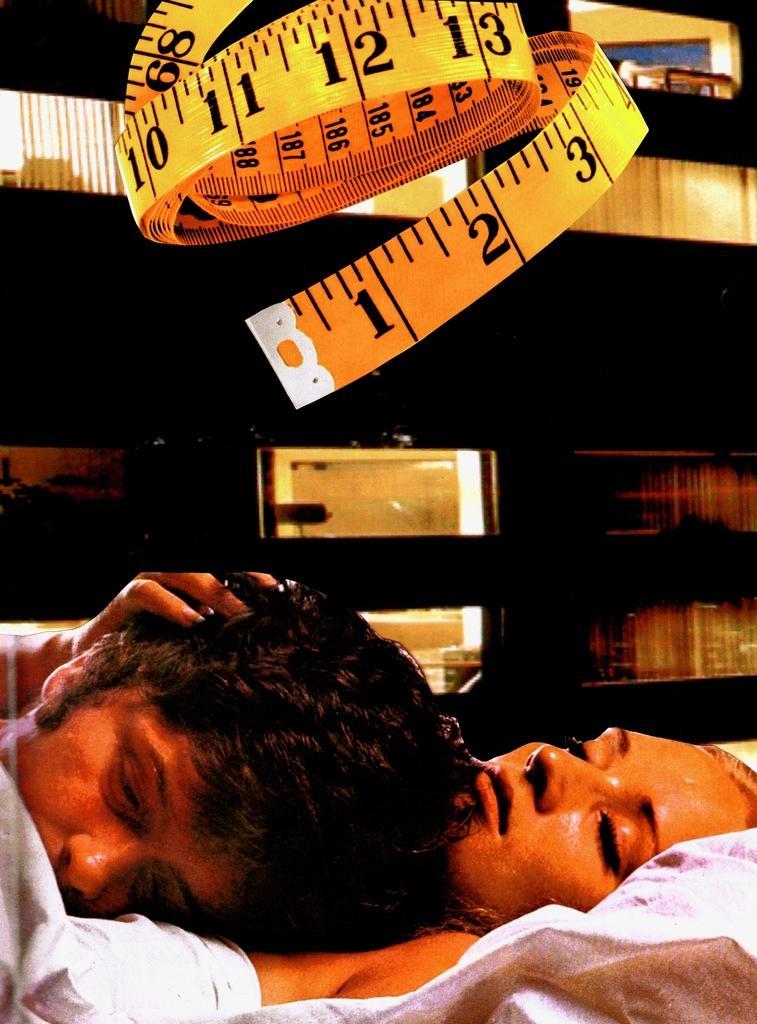Could you give a brief overview of what you see in this image? In this image, we can see a man lying on a lady and at the top, there is a tape. 